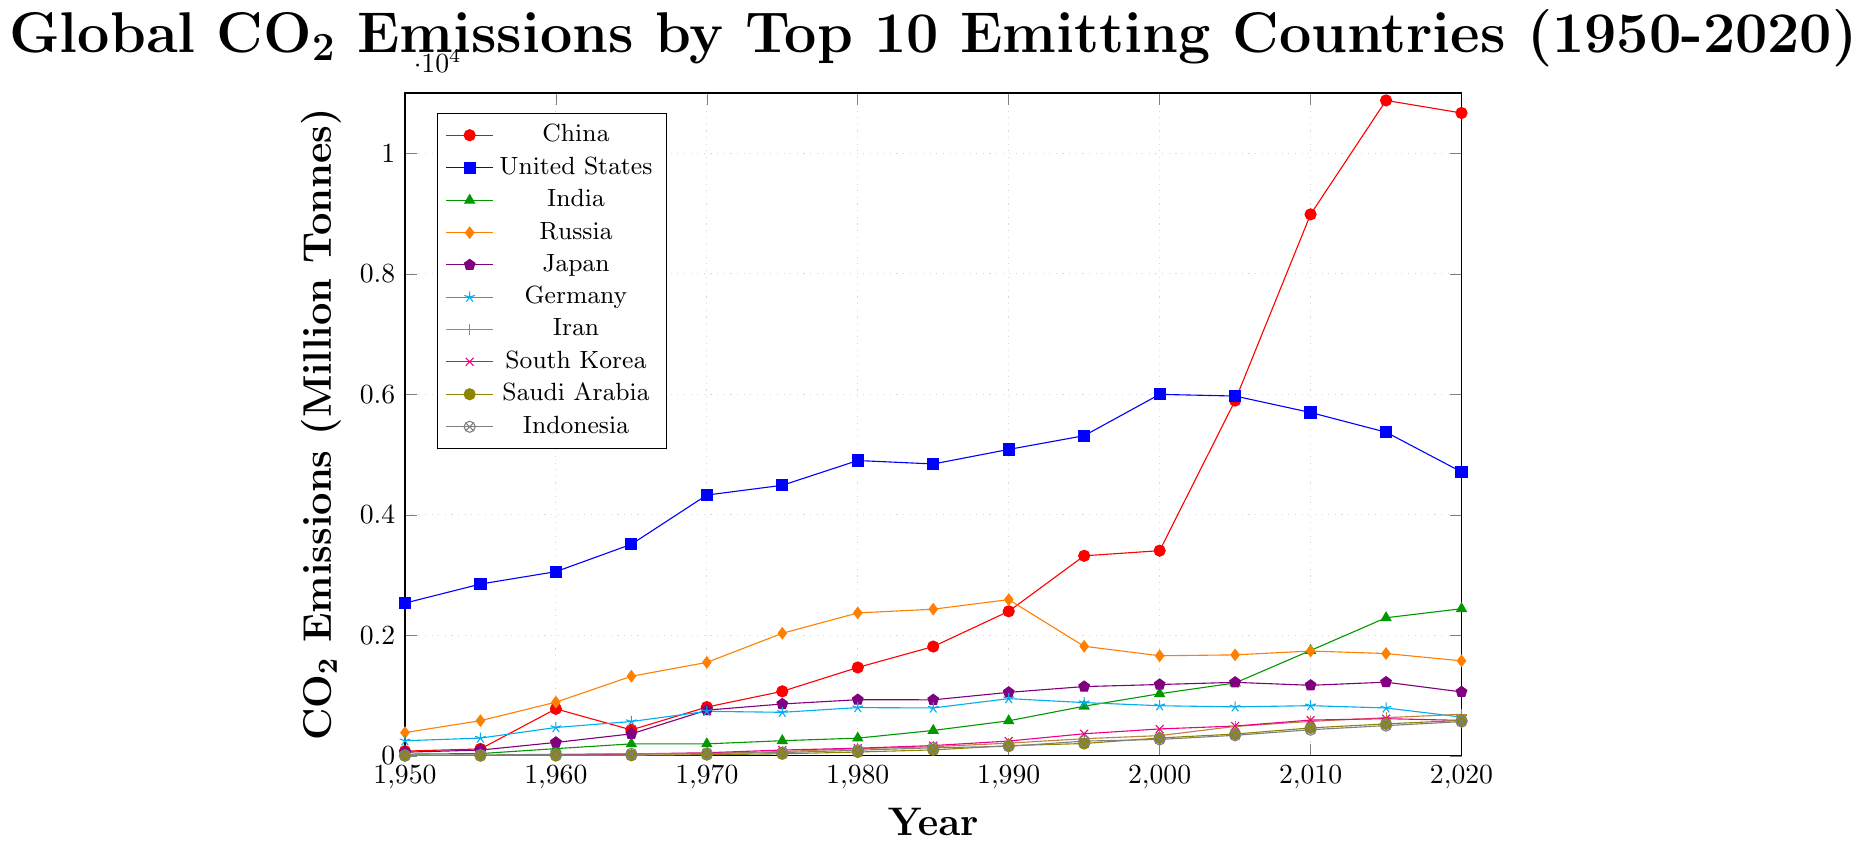What was the trend of CO2 emissions from China between 1950 and 2020? The emissions from China exhibited an upward trend from 1950 to 2020. Starting around 79 million tonnes in 1950, China's CO2 emissions increased significantly, reaching the highest level of 10,877 million tonnes by 2015. A slight decrease followed in 2020 to 10,668 million tonnes.
Answer: Increasing trend Which country had the highest CO2 emissions in 1950 and how much was it? In 1950, the United States had the highest CO2 emissions, amounting to 2,535 million tonnes. This is determined by analyzing the starting values for each country, where the United States' value is the largest.
Answer: United States, 2,535 million tonnes Compare the CO2 emissions of India and Russia in 2020. Which country had higher emissions? India's CO2 emissions in 2020 were 2,442 million tonnes, while Russia's emissions were 1,577 million tonnes. By comparing these two values, we find that India's emissions were higher.
Answer: India What was the difference in CO2 emissions between Japan and Germany in 1980? In 1980, Japan's CO2 emissions were 932 million tonnes, and Germany's were 801 million tonnes. The difference is calculated by subtracting Germany's emissions from Japan's emissions: 932 - 801 = 131.
Answer: 131 million tonnes How did the CO2 emissions of the United States change from 2000 to 2020? In 2000, the CO2 emissions for the United States were 5,999 million tonnes, and in 2020, they were 4,712 million tonnes. The change is found by subtracting the 2020 value from the 2000 value: 5,999 - 4,712 = 1,287 million tonnes. Hence, emissions decreased by 1,287 million tonnes.
Answer: Decreased by 1,287 million tonnes Which country had the most significant increase in CO2 emissions from 1950 to 2020? Between 1950 and 2020, China experienced the most significant increase in CO2 emissions. Starting from 79 million tonnes in 1950 to 10,668 million tonnes in 2020, the net increase is: 10,668 - 79 = 10,589 million tonnes.
Answer: China What is the general trend in the CO2 emissions of Germany from 1990 to 2020? From 1990 (950 million tonnes) to 2020 (644 million tonnes), Germany's CO2 emissions show a decreasing trend. This can be seen as the values gradually reduce over the given period.
Answer: Decreasing trend Compare the CO2 emissions of Iran and South Korea in 2015. Which country emitted more CO2? In 2015, Iran's CO2 emissions were 634 million tonnes, whereas South Korea's emissions were 617 million tonnes. Comparing these values, Iran had higher emissions.
Answer: Iran What was the percentage increase in CO2 emissions for India from 1990 to 2020? India’s CO2 emissions in 1990 were 582 million tonnes and in 2020 were 2,442 million tonnes. The percentage increase is calculated as: \[\left(\frac{{2442 - 582}}{582}\right) \times 100 = 319.24\%\]
Answer: Approximately 319.24% How did Saudi Arabia's CO2 emissions change from 1970 to 2020? In 1970, Saudi Arabia’s CO2 emissions were 20 million tonnes, which increased to 588 million tonnes by 2020. The change is computed as: 588 - 20 = 568 million tonnes, indicating a significant increase.
Answer: Increased by 568 million tonnes 